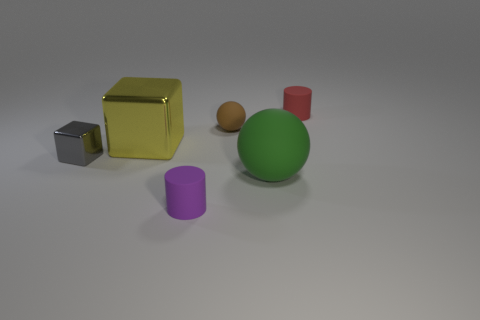What number of things are either tiny spheres or things that are left of the large rubber object?
Make the answer very short. 4. Is there a green rubber thing of the same size as the purple rubber thing?
Make the answer very short. No. Are the red thing and the big block made of the same material?
Provide a succinct answer. No. How many objects are tiny purple cylinders or tiny blue cylinders?
Make the answer very short. 1. The purple rubber thing is what size?
Your response must be concise. Small. Are there fewer tiny purple matte cylinders than big green cubes?
Ensure brevity in your answer.  No. What is the shape of the object that is left of the big block?
Make the answer very short. Cube. There is a metallic cube left of the big yellow object; are there any tiny gray metallic objects behind it?
Make the answer very short. No. How many tiny cylinders have the same material as the gray cube?
Make the answer very short. 0. There is a rubber sphere in front of the big yellow metal cube that is left of the small thing to the right of the small sphere; what is its size?
Provide a succinct answer. Large. 